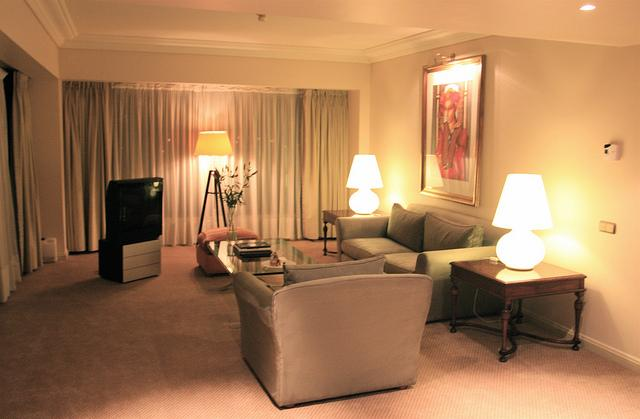What is the large black object used for? watching television 